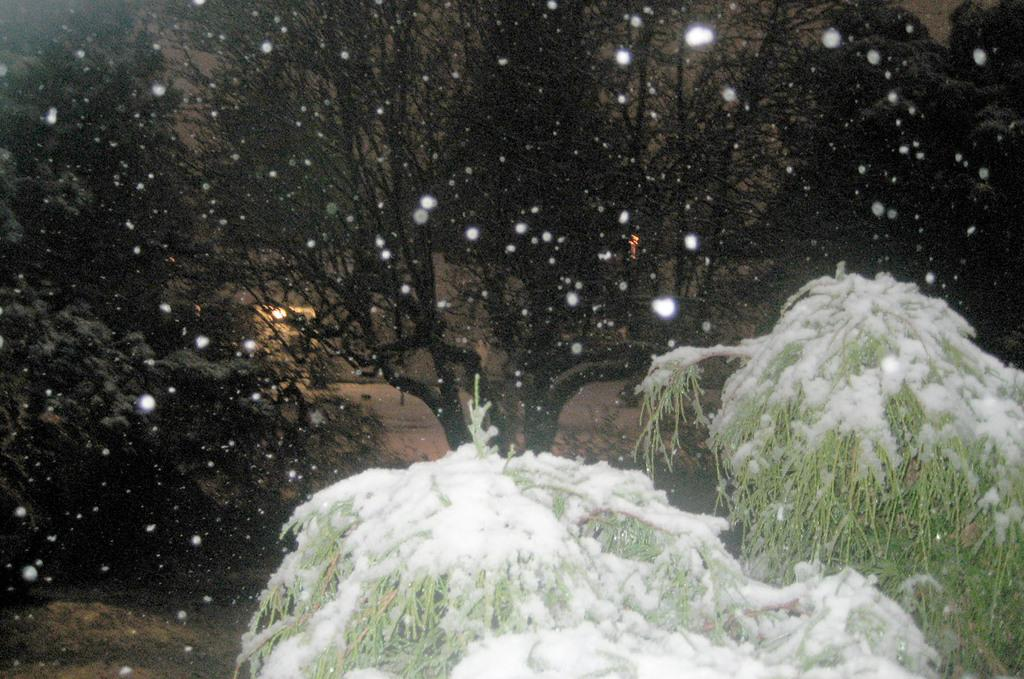What is covering the plants in the image? There is snow on the plants in the image. What can be seen in the background of the image? There are trees in the background of the image. What type of ornament is hanging from the curtain in the image? There is no curtain or ornament present in the image; it features snow-covered plants and trees in the background. 